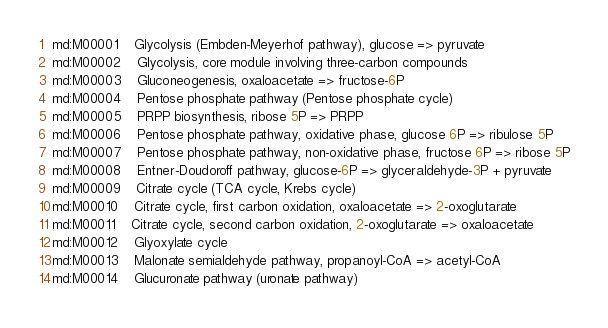<code> <loc_0><loc_0><loc_500><loc_500><_SQL_>md:M00001	Glycolysis (Embden-Meyerhof pathway), glucose => pyruvate
md:M00002	Glycolysis, core module involving three-carbon compounds
md:M00003	Gluconeogenesis, oxaloacetate => fructose-6P
md:M00004	Pentose phosphate pathway (Pentose phosphate cycle)
md:M00005	PRPP biosynthesis, ribose 5P => PRPP
md:M00006	Pentose phosphate pathway, oxidative phase, glucose 6P => ribulose 5P
md:M00007	Pentose phosphate pathway, non-oxidative phase, fructose 6P => ribose 5P
md:M00008	Entner-Doudoroff pathway, glucose-6P => glyceraldehyde-3P + pyruvate
md:M00009	Citrate cycle (TCA cycle, Krebs cycle)
md:M00010	Citrate cycle, first carbon oxidation, oxaloacetate => 2-oxoglutarate
md:M00011	Citrate cycle, second carbon oxidation, 2-oxoglutarate => oxaloacetate
md:M00012	Glyoxylate cycle
md:M00013	Malonate semialdehyde pathway, propanoyl-CoA => acetyl-CoA
md:M00014	Glucuronate pathway (uronate pathway)</code> 